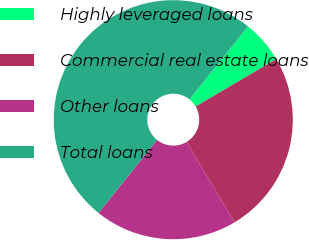<chart> <loc_0><loc_0><loc_500><loc_500><pie_chart><fcel>Highly leveraged loans<fcel>Commercial real estate loans<fcel>Other loans<fcel>Total loans<nl><fcel>5.78%<fcel>24.89%<fcel>19.33%<fcel>50.0%<nl></chart> 